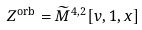Convert formula to latex. <formula><loc_0><loc_0><loc_500><loc_500>Z ^ { \text {orb} } & = \widetilde { M } ^ { 4 , 2 } [ v , 1 , x ]</formula> 